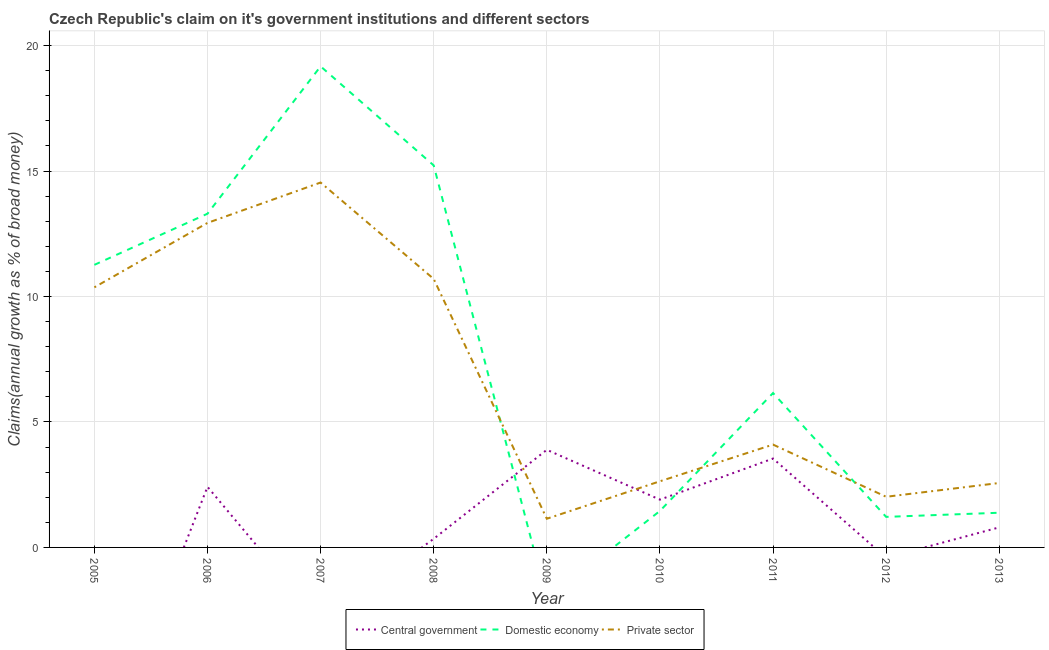How many different coloured lines are there?
Keep it short and to the point. 3. Does the line corresponding to percentage of claim on the domestic economy intersect with the line corresponding to percentage of claim on the private sector?
Your answer should be compact. Yes. Is the number of lines equal to the number of legend labels?
Your answer should be very brief. No. What is the percentage of claim on the private sector in 2007?
Your answer should be very brief. 14.54. Across all years, what is the maximum percentage of claim on the domestic economy?
Keep it short and to the point. 19.17. In which year was the percentage of claim on the domestic economy maximum?
Provide a succinct answer. 2007. What is the total percentage of claim on the domestic economy in the graph?
Offer a very short reply. 69.17. What is the difference between the percentage of claim on the domestic economy in 2007 and that in 2012?
Ensure brevity in your answer.  17.96. What is the difference between the percentage of claim on the domestic economy in 2010 and the percentage of claim on the central government in 2008?
Make the answer very short. 1.11. What is the average percentage of claim on the private sector per year?
Give a very brief answer. 6.78. In the year 2011, what is the difference between the percentage of claim on the private sector and percentage of claim on the domestic economy?
Ensure brevity in your answer.  -2.05. In how many years, is the percentage of claim on the central government greater than 1 %?
Make the answer very short. 4. What is the ratio of the percentage of claim on the private sector in 2008 to that in 2010?
Offer a very short reply. 4.06. Is the percentage of claim on the central government in 2009 less than that in 2011?
Your answer should be very brief. No. Is the difference between the percentage of claim on the domestic economy in 2010 and 2011 greater than the difference between the percentage of claim on the private sector in 2010 and 2011?
Offer a terse response. No. What is the difference between the highest and the second highest percentage of claim on the central government?
Your answer should be compact. 0.35. What is the difference between the highest and the lowest percentage of claim on the domestic economy?
Your response must be concise. 19.17. Is the sum of the percentage of claim on the domestic economy in 2008 and 2013 greater than the maximum percentage of claim on the private sector across all years?
Your response must be concise. Yes. Is the percentage of claim on the central government strictly greater than the percentage of claim on the domestic economy over the years?
Provide a succinct answer. No. How many lines are there?
Offer a very short reply. 3. How many years are there in the graph?
Your answer should be very brief. 9. What is the difference between two consecutive major ticks on the Y-axis?
Make the answer very short. 5. Does the graph contain any zero values?
Your answer should be very brief. Yes. How many legend labels are there?
Your response must be concise. 3. What is the title of the graph?
Your answer should be compact. Czech Republic's claim on it's government institutions and different sectors. Does "Infant(male)" appear as one of the legend labels in the graph?
Offer a very short reply. No. What is the label or title of the Y-axis?
Keep it short and to the point. Claims(annual growth as % of broad money). What is the Claims(annual growth as % of broad money) in Central government in 2005?
Your answer should be compact. 0. What is the Claims(annual growth as % of broad money) of Domestic economy in 2005?
Provide a short and direct response. 11.26. What is the Claims(annual growth as % of broad money) in Private sector in 2005?
Provide a succinct answer. 10.37. What is the Claims(annual growth as % of broad money) in Central government in 2006?
Your answer should be very brief. 2.42. What is the Claims(annual growth as % of broad money) in Domestic economy in 2006?
Keep it short and to the point. 13.3. What is the Claims(annual growth as % of broad money) in Private sector in 2006?
Offer a terse response. 12.93. What is the Claims(annual growth as % of broad money) of Central government in 2007?
Ensure brevity in your answer.  0. What is the Claims(annual growth as % of broad money) of Domestic economy in 2007?
Your answer should be very brief. 19.17. What is the Claims(annual growth as % of broad money) in Private sector in 2007?
Your answer should be very brief. 14.54. What is the Claims(annual growth as % of broad money) of Central government in 2008?
Give a very brief answer. 0.34. What is the Claims(annual growth as % of broad money) of Domestic economy in 2008?
Your response must be concise. 15.22. What is the Claims(annual growth as % of broad money) of Private sector in 2008?
Make the answer very short. 10.7. What is the Claims(annual growth as % of broad money) in Central government in 2009?
Make the answer very short. 3.89. What is the Claims(annual growth as % of broad money) of Domestic economy in 2009?
Your response must be concise. 0. What is the Claims(annual growth as % of broad money) of Private sector in 2009?
Your answer should be very brief. 1.14. What is the Claims(annual growth as % of broad money) of Central government in 2010?
Offer a terse response. 1.9. What is the Claims(annual growth as % of broad money) of Domestic economy in 2010?
Provide a succinct answer. 1.45. What is the Claims(annual growth as % of broad money) in Private sector in 2010?
Ensure brevity in your answer.  2.64. What is the Claims(annual growth as % of broad money) in Central government in 2011?
Give a very brief answer. 3.54. What is the Claims(annual growth as % of broad money) in Domestic economy in 2011?
Make the answer very short. 6.15. What is the Claims(annual growth as % of broad money) of Private sector in 2011?
Offer a very short reply. 4.1. What is the Claims(annual growth as % of broad money) of Domestic economy in 2012?
Your response must be concise. 1.22. What is the Claims(annual growth as % of broad money) in Private sector in 2012?
Give a very brief answer. 2.02. What is the Claims(annual growth as % of broad money) of Central government in 2013?
Your answer should be compact. 0.8. What is the Claims(annual growth as % of broad money) in Domestic economy in 2013?
Your answer should be very brief. 1.38. What is the Claims(annual growth as % of broad money) in Private sector in 2013?
Your answer should be compact. 2.57. Across all years, what is the maximum Claims(annual growth as % of broad money) of Central government?
Make the answer very short. 3.89. Across all years, what is the maximum Claims(annual growth as % of broad money) of Domestic economy?
Keep it short and to the point. 19.17. Across all years, what is the maximum Claims(annual growth as % of broad money) of Private sector?
Offer a very short reply. 14.54. Across all years, what is the minimum Claims(annual growth as % of broad money) in Central government?
Your answer should be compact. 0. Across all years, what is the minimum Claims(annual growth as % of broad money) in Private sector?
Keep it short and to the point. 1.14. What is the total Claims(annual growth as % of broad money) in Central government in the graph?
Keep it short and to the point. 12.9. What is the total Claims(annual growth as % of broad money) of Domestic economy in the graph?
Your answer should be very brief. 69.17. What is the total Claims(annual growth as % of broad money) in Private sector in the graph?
Keep it short and to the point. 61. What is the difference between the Claims(annual growth as % of broad money) of Domestic economy in 2005 and that in 2006?
Offer a terse response. -2.04. What is the difference between the Claims(annual growth as % of broad money) of Private sector in 2005 and that in 2006?
Provide a succinct answer. -2.57. What is the difference between the Claims(annual growth as % of broad money) of Domestic economy in 2005 and that in 2007?
Offer a terse response. -7.91. What is the difference between the Claims(annual growth as % of broad money) of Private sector in 2005 and that in 2007?
Make the answer very short. -4.18. What is the difference between the Claims(annual growth as % of broad money) in Domestic economy in 2005 and that in 2008?
Offer a terse response. -3.96. What is the difference between the Claims(annual growth as % of broad money) in Private sector in 2005 and that in 2008?
Ensure brevity in your answer.  -0.33. What is the difference between the Claims(annual growth as % of broad money) in Private sector in 2005 and that in 2009?
Make the answer very short. 9.22. What is the difference between the Claims(annual growth as % of broad money) of Domestic economy in 2005 and that in 2010?
Your answer should be very brief. 9.81. What is the difference between the Claims(annual growth as % of broad money) in Private sector in 2005 and that in 2010?
Your answer should be very brief. 7.73. What is the difference between the Claims(annual growth as % of broad money) of Domestic economy in 2005 and that in 2011?
Give a very brief answer. 5.11. What is the difference between the Claims(annual growth as % of broad money) of Private sector in 2005 and that in 2011?
Offer a terse response. 6.27. What is the difference between the Claims(annual growth as % of broad money) in Domestic economy in 2005 and that in 2012?
Your response must be concise. 10.04. What is the difference between the Claims(annual growth as % of broad money) of Private sector in 2005 and that in 2012?
Ensure brevity in your answer.  8.35. What is the difference between the Claims(annual growth as % of broad money) in Domestic economy in 2005 and that in 2013?
Your answer should be compact. 9.88. What is the difference between the Claims(annual growth as % of broad money) in Private sector in 2005 and that in 2013?
Your answer should be compact. 7.8. What is the difference between the Claims(annual growth as % of broad money) in Domestic economy in 2006 and that in 2007?
Ensure brevity in your answer.  -5.87. What is the difference between the Claims(annual growth as % of broad money) in Private sector in 2006 and that in 2007?
Keep it short and to the point. -1.61. What is the difference between the Claims(annual growth as % of broad money) of Central government in 2006 and that in 2008?
Provide a short and direct response. 2.07. What is the difference between the Claims(annual growth as % of broad money) of Domestic economy in 2006 and that in 2008?
Ensure brevity in your answer.  -1.93. What is the difference between the Claims(annual growth as % of broad money) in Private sector in 2006 and that in 2008?
Your response must be concise. 2.23. What is the difference between the Claims(annual growth as % of broad money) in Central government in 2006 and that in 2009?
Offer a very short reply. -1.48. What is the difference between the Claims(annual growth as % of broad money) in Private sector in 2006 and that in 2009?
Provide a short and direct response. 11.79. What is the difference between the Claims(annual growth as % of broad money) in Central government in 2006 and that in 2010?
Ensure brevity in your answer.  0.51. What is the difference between the Claims(annual growth as % of broad money) of Domestic economy in 2006 and that in 2010?
Your answer should be compact. 11.84. What is the difference between the Claims(annual growth as % of broad money) in Private sector in 2006 and that in 2010?
Ensure brevity in your answer.  10.3. What is the difference between the Claims(annual growth as % of broad money) in Central government in 2006 and that in 2011?
Make the answer very short. -1.13. What is the difference between the Claims(annual growth as % of broad money) in Domestic economy in 2006 and that in 2011?
Your response must be concise. 7.15. What is the difference between the Claims(annual growth as % of broad money) in Private sector in 2006 and that in 2011?
Ensure brevity in your answer.  8.83. What is the difference between the Claims(annual growth as % of broad money) of Domestic economy in 2006 and that in 2012?
Your answer should be very brief. 12.08. What is the difference between the Claims(annual growth as % of broad money) of Private sector in 2006 and that in 2012?
Your answer should be compact. 10.91. What is the difference between the Claims(annual growth as % of broad money) in Central government in 2006 and that in 2013?
Offer a very short reply. 1.62. What is the difference between the Claims(annual growth as % of broad money) in Domestic economy in 2006 and that in 2013?
Your answer should be compact. 11.92. What is the difference between the Claims(annual growth as % of broad money) in Private sector in 2006 and that in 2013?
Make the answer very short. 10.36. What is the difference between the Claims(annual growth as % of broad money) of Domestic economy in 2007 and that in 2008?
Provide a short and direct response. 3.95. What is the difference between the Claims(annual growth as % of broad money) of Private sector in 2007 and that in 2008?
Your answer should be compact. 3.84. What is the difference between the Claims(annual growth as % of broad money) in Private sector in 2007 and that in 2009?
Give a very brief answer. 13.4. What is the difference between the Claims(annual growth as % of broad money) in Domestic economy in 2007 and that in 2010?
Make the answer very short. 17.72. What is the difference between the Claims(annual growth as % of broad money) in Private sector in 2007 and that in 2010?
Provide a short and direct response. 11.91. What is the difference between the Claims(annual growth as % of broad money) of Domestic economy in 2007 and that in 2011?
Offer a very short reply. 13.02. What is the difference between the Claims(annual growth as % of broad money) in Private sector in 2007 and that in 2011?
Provide a short and direct response. 10.44. What is the difference between the Claims(annual growth as % of broad money) in Domestic economy in 2007 and that in 2012?
Your answer should be very brief. 17.96. What is the difference between the Claims(annual growth as % of broad money) of Private sector in 2007 and that in 2012?
Your response must be concise. 12.52. What is the difference between the Claims(annual growth as % of broad money) in Domestic economy in 2007 and that in 2013?
Your answer should be compact. 17.79. What is the difference between the Claims(annual growth as % of broad money) of Private sector in 2007 and that in 2013?
Ensure brevity in your answer.  11.97. What is the difference between the Claims(annual growth as % of broad money) in Central government in 2008 and that in 2009?
Keep it short and to the point. -3.55. What is the difference between the Claims(annual growth as % of broad money) of Private sector in 2008 and that in 2009?
Give a very brief answer. 9.56. What is the difference between the Claims(annual growth as % of broad money) of Central government in 2008 and that in 2010?
Offer a terse response. -1.56. What is the difference between the Claims(annual growth as % of broad money) in Domestic economy in 2008 and that in 2010?
Make the answer very short. 13.77. What is the difference between the Claims(annual growth as % of broad money) in Private sector in 2008 and that in 2010?
Offer a very short reply. 8.06. What is the difference between the Claims(annual growth as % of broad money) of Central government in 2008 and that in 2011?
Make the answer very short. -3.2. What is the difference between the Claims(annual growth as % of broad money) of Domestic economy in 2008 and that in 2011?
Make the answer very short. 9.07. What is the difference between the Claims(annual growth as % of broad money) of Private sector in 2008 and that in 2011?
Provide a short and direct response. 6.6. What is the difference between the Claims(annual growth as % of broad money) in Domestic economy in 2008 and that in 2012?
Give a very brief answer. 14.01. What is the difference between the Claims(annual growth as % of broad money) in Private sector in 2008 and that in 2012?
Provide a short and direct response. 8.68. What is the difference between the Claims(annual growth as % of broad money) in Central government in 2008 and that in 2013?
Your answer should be very brief. -0.46. What is the difference between the Claims(annual growth as % of broad money) of Domestic economy in 2008 and that in 2013?
Offer a very short reply. 13.84. What is the difference between the Claims(annual growth as % of broad money) in Private sector in 2008 and that in 2013?
Keep it short and to the point. 8.13. What is the difference between the Claims(annual growth as % of broad money) in Central government in 2009 and that in 2010?
Make the answer very short. 1.99. What is the difference between the Claims(annual growth as % of broad money) in Private sector in 2009 and that in 2010?
Provide a succinct answer. -1.49. What is the difference between the Claims(annual growth as % of broad money) of Central government in 2009 and that in 2011?
Ensure brevity in your answer.  0.35. What is the difference between the Claims(annual growth as % of broad money) of Private sector in 2009 and that in 2011?
Your response must be concise. -2.95. What is the difference between the Claims(annual growth as % of broad money) in Private sector in 2009 and that in 2012?
Offer a very short reply. -0.88. What is the difference between the Claims(annual growth as % of broad money) of Central government in 2009 and that in 2013?
Provide a succinct answer. 3.09. What is the difference between the Claims(annual growth as % of broad money) of Private sector in 2009 and that in 2013?
Your answer should be compact. -1.42. What is the difference between the Claims(annual growth as % of broad money) of Central government in 2010 and that in 2011?
Give a very brief answer. -1.64. What is the difference between the Claims(annual growth as % of broad money) of Domestic economy in 2010 and that in 2011?
Offer a terse response. -4.7. What is the difference between the Claims(annual growth as % of broad money) in Private sector in 2010 and that in 2011?
Your answer should be compact. -1.46. What is the difference between the Claims(annual growth as % of broad money) in Domestic economy in 2010 and that in 2012?
Keep it short and to the point. 0.24. What is the difference between the Claims(annual growth as % of broad money) of Private sector in 2010 and that in 2012?
Provide a succinct answer. 0.62. What is the difference between the Claims(annual growth as % of broad money) of Central government in 2010 and that in 2013?
Ensure brevity in your answer.  1.1. What is the difference between the Claims(annual growth as % of broad money) of Domestic economy in 2010 and that in 2013?
Make the answer very short. 0.07. What is the difference between the Claims(annual growth as % of broad money) of Private sector in 2010 and that in 2013?
Your answer should be very brief. 0.07. What is the difference between the Claims(annual growth as % of broad money) in Domestic economy in 2011 and that in 2012?
Offer a terse response. 4.94. What is the difference between the Claims(annual growth as % of broad money) of Private sector in 2011 and that in 2012?
Your response must be concise. 2.08. What is the difference between the Claims(annual growth as % of broad money) in Central government in 2011 and that in 2013?
Provide a succinct answer. 2.74. What is the difference between the Claims(annual growth as % of broad money) in Domestic economy in 2011 and that in 2013?
Give a very brief answer. 4.77. What is the difference between the Claims(annual growth as % of broad money) of Private sector in 2011 and that in 2013?
Your response must be concise. 1.53. What is the difference between the Claims(annual growth as % of broad money) in Domestic economy in 2012 and that in 2013?
Give a very brief answer. -0.17. What is the difference between the Claims(annual growth as % of broad money) in Private sector in 2012 and that in 2013?
Make the answer very short. -0.55. What is the difference between the Claims(annual growth as % of broad money) in Domestic economy in 2005 and the Claims(annual growth as % of broad money) in Private sector in 2006?
Provide a short and direct response. -1.67. What is the difference between the Claims(annual growth as % of broad money) of Domestic economy in 2005 and the Claims(annual growth as % of broad money) of Private sector in 2007?
Make the answer very short. -3.28. What is the difference between the Claims(annual growth as % of broad money) of Domestic economy in 2005 and the Claims(annual growth as % of broad money) of Private sector in 2008?
Offer a very short reply. 0.56. What is the difference between the Claims(annual growth as % of broad money) in Domestic economy in 2005 and the Claims(annual growth as % of broad money) in Private sector in 2009?
Your answer should be compact. 10.12. What is the difference between the Claims(annual growth as % of broad money) of Domestic economy in 2005 and the Claims(annual growth as % of broad money) of Private sector in 2010?
Your answer should be compact. 8.63. What is the difference between the Claims(annual growth as % of broad money) of Domestic economy in 2005 and the Claims(annual growth as % of broad money) of Private sector in 2011?
Your response must be concise. 7.16. What is the difference between the Claims(annual growth as % of broad money) of Domestic economy in 2005 and the Claims(annual growth as % of broad money) of Private sector in 2012?
Your answer should be very brief. 9.24. What is the difference between the Claims(annual growth as % of broad money) in Domestic economy in 2005 and the Claims(annual growth as % of broad money) in Private sector in 2013?
Provide a succinct answer. 8.69. What is the difference between the Claims(annual growth as % of broad money) in Central government in 2006 and the Claims(annual growth as % of broad money) in Domestic economy in 2007?
Your answer should be very brief. -16.76. What is the difference between the Claims(annual growth as % of broad money) in Central government in 2006 and the Claims(annual growth as % of broad money) in Private sector in 2007?
Keep it short and to the point. -12.13. What is the difference between the Claims(annual growth as % of broad money) in Domestic economy in 2006 and the Claims(annual growth as % of broad money) in Private sector in 2007?
Offer a terse response. -1.24. What is the difference between the Claims(annual growth as % of broad money) of Central government in 2006 and the Claims(annual growth as % of broad money) of Domestic economy in 2008?
Your response must be concise. -12.81. What is the difference between the Claims(annual growth as % of broad money) in Central government in 2006 and the Claims(annual growth as % of broad money) in Private sector in 2008?
Ensure brevity in your answer.  -8.28. What is the difference between the Claims(annual growth as % of broad money) in Domestic economy in 2006 and the Claims(annual growth as % of broad money) in Private sector in 2008?
Offer a terse response. 2.6. What is the difference between the Claims(annual growth as % of broad money) of Central government in 2006 and the Claims(annual growth as % of broad money) of Private sector in 2009?
Offer a terse response. 1.27. What is the difference between the Claims(annual growth as % of broad money) of Domestic economy in 2006 and the Claims(annual growth as % of broad money) of Private sector in 2009?
Provide a succinct answer. 12.16. What is the difference between the Claims(annual growth as % of broad money) in Central government in 2006 and the Claims(annual growth as % of broad money) in Domestic economy in 2010?
Give a very brief answer. 0.96. What is the difference between the Claims(annual growth as % of broad money) of Central government in 2006 and the Claims(annual growth as % of broad money) of Private sector in 2010?
Keep it short and to the point. -0.22. What is the difference between the Claims(annual growth as % of broad money) in Domestic economy in 2006 and the Claims(annual growth as % of broad money) in Private sector in 2010?
Your response must be concise. 10.66. What is the difference between the Claims(annual growth as % of broad money) in Central government in 2006 and the Claims(annual growth as % of broad money) in Domestic economy in 2011?
Your answer should be compact. -3.74. What is the difference between the Claims(annual growth as % of broad money) in Central government in 2006 and the Claims(annual growth as % of broad money) in Private sector in 2011?
Offer a very short reply. -1.68. What is the difference between the Claims(annual growth as % of broad money) of Domestic economy in 2006 and the Claims(annual growth as % of broad money) of Private sector in 2011?
Make the answer very short. 9.2. What is the difference between the Claims(annual growth as % of broad money) of Central government in 2006 and the Claims(annual growth as % of broad money) of Domestic economy in 2012?
Ensure brevity in your answer.  1.2. What is the difference between the Claims(annual growth as % of broad money) of Central government in 2006 and the Claims(annual growth as % of broad money) of Private sector in 2012?
Offer a terse response. 0.4. What is the difference between the Claims(annual growth as % of broad money) in Domestic economy in 2006 and the Claims(annual growth as % of broad money) in Private sector in 2012?
Your answer should be compact. 11.28. What is the difference between the Claims(annual growth as % of broad money) in Central government in 2006 and the Claims(annual growth as % of broad money) in Domestic economy in 2013?
Give a very brief answer. 1.03. What is the difference between the Claims(annual growth as % of broad money) of Central government in 2006 and the Claims(annual growth as % of broad money) of Private sector in 2013?
Ensure brevity in your answer.  -0.15. What is the difference between the Claims(annual growth as % of broad money) of Domestic economy in 2006 and the Claims(annual growth as % of broad money) of Private sector in 2013?
Provide a short and direct response. 10.73. What is the difference between the Claims(annual growth as % of broad money) of Domestic economy in 2007 and the Claims(annual growth as % of broad money) of Private sector in 2008?
Ensure brevity in your answer.  8.47. What is the difference between the Claims(annual growth as % of broad money) of Domestic economy in 2007 and the Claims(annual growth as % of broad money) of Private sector in 2009?
Your answer should be very brief. 18.03. What is the difference between the Claims(annual growth as % of broad money) of Domestic economy in 2007 and the Claims(annual growth as % of broad money) of Private sector in 2010?
Keep it short and to the point. 16.54. What is the difference between the Claims(annual growth as % of broad money) of Domestic economy in 2007 and the Claims(annual growth as % of broad money) of Private sector in 2011?
Keep it short and to the point. 15.07. What is the difference between the Claims(annual growth as % of broad money) in Domestic economy in 2007 and the Claims(annual growth as % of broad money) in Private sector in 2012?
Make the answer very short. 17.15. What is the difference between the Claims(annual growth as % of broad money) in Domestic economy in 2007 and the Claims(annual growth as % of broad money) in Private sector in 2013?
Offer a terse response. 16.6. What is the difference between the Claims(annual growth as % of broad money) of Central government in 2008 and the Claims(annual growth as % of broad money) of Private sector in 2009?
Your response must be concise. -0.8. What is the difference between the Claims(annual growth as % of broad money) in Domestic economy in 2008 and the Claims(annual growth as % of broad money) in Private sector in 2009?
Your response must be concise. 14.08. What is the difference between the Claims(annual growth as % of broad money) of Central government in 2008 and the Claims(annual growth as % of broad money) of Domestic economy in 2010?
Offer a very short reply. -1.11. What is the difference between the Claims(annual growth as % of broad money) of Central government in 2008 and the Claims(annual growth as % of broad money) of Private sector in 2010?
Your response must be concise. -2.29. What is the difference between the Claims(annual growth as % of broad money) in Domestic economy in 2008 and the Claims(annual growth as % of broad money) in Private sector in 2010?
Ensure brevity in your answer.  12.59. What is the difference between the Claims(annual growth as % of broad money) in Central government in 2008 and the Claims(annual growth as % of broad money) in Domestic economy in 2011?
Offer a terse response. -5.81. What is the difference between the Claims(annual growth as % of broad money) in Central government in 2008 and the Claims(annual growth as % of broad money) in Private sector in 2011?
Keep it short and to the point. -3.75. What is the difference between the Claims(annual growth as % of broad money) of Domestic economy in 2008 and the Claims(annual growth as % of broad money) of Private sector in 2011?
Give a very brief answer. 11.13. What is the difference between the Claims(annual growth as % of broad money) of Central government in 2008 and the Claims(annual growth as % of broad money) of Domestic economy in 2012?
Keep it short and to the point. -0.87. What is the difference between the Claims(annual growth as % of broad money) of Central government in 2008 and the Claims(annual growth as % of broad money) of Private sector in 2012?
Your answer should be compact. -1.67. What is the difference between the Claims(annual growth as % of broad money) in Domestic economy in 2008 and the Claims(annual growth as % of broad money) in Private sector in 2012?
Offer a very short reply. 13.21. What is the difference between the Claims(annual growth as % of broad money) in Central government in 2008 and the Claims(annual growth as % of broad money) in Domestic economy in 2013?
Your answer should be very brief. -1.04. What is the difference between the Claims(annual growth as % of broad money) of Central government in 2008 and the Claims(annual growth as % of broad money) of Private sector in 2013?
Give a very brief answer. -2.22. What is the difference between the Claims(annual growth as % of broad money) of Domestic economy in 2008 and the Claims(annual growth as % of broad money) of Private sector in 2013?
Ensure brevity in your answer.  12.66. What is the difference between the Claims(annual growth as % of broad money) of Central government in 2009 and the Claims(annual growth as % of broad money) of Domestic economy in 2010?
Make the answer very short. 2.44. What is the difference between the Claims(annual growth as % of broad money) of Central government in 2009 and the Claims(annual growth as % of broad money) of Private sector in 2010?
Make the answer very short. 1.25. What is the difference between the Claims(annual growth as % of broad money) of Central government in 2009 and the Claims(annual growth as % of broad money) of Domestic economy in 2011?
Your answer should be very brief. -2.26. What is the difference between the Claims(annual growth as % of broad money) of Central government in 2009 and the Claims(annual growth as % of broad money) of Private sector in 2011?
Provide a succinct answer. -0.21. What is the difference between the Claims(annual growth as % of broad money) of Central government in 2009 and the Claims(annual growth as % of broad money) of Domestic economy in 2012?
Ensure brevity in your answer.  2.67. What is the difference between the Claims(annual growth as % of broad money) in Central government in 2009 and the Claims(annual growth as % of broad money) in Private sector in 2012?
Give a very brief answer. 1.87. What is the difference between the Claims(annual growth as % of broad money) of Central government in 2009 and the Claims(annual growth as % of broad money) of Domestic economy in 2013?
Offer a terse response. 2.51. What is the difference between the Claims(annual growth as % of broad money) in Central government in 2009 and the Claims(annual growth as % of broad money) in Private sector in 2013?
Provide a short and direct response. 1.32. What is the difference between the Claims(annual growth as % of broad money) of Central government in 2010 and the Claims(annual growth as % of broad money) of Domestic economy in 2011?
Make the answer very short. -4.25. What is the difference between the Claims(annual growth as % of broad money) in Central government in 2010 and the Claims(annual growth as % of broad money) in Private sector in 2011?
Offer a very short reply. -2.19. What is the difference between the Claims(annual growth as % of broad money) in Domestic economy in 2010 and the Claims(annual growth as % of broad money) in Private sector in 2011?
Offer a terse response. -2.64. What is the difference between the Claims(annual growth as % of broad money) in Central government in 2010 and the Claims(annual growth as % of broad money) in Domestic economy in 2012?
Your response must be concise. 0.69. What is the difference between the Claims(annual growth as % of broad money) of Central government in 2010 and the Claims(annual growth as % of broad money) of Private sector in 2012?
Offer a terse response. -0.11. What is the difference between the Claims(annual growth as % of broad money) of Domestic economy in 2010 and the Claims(annual growth as % of broad money) of Private sector in 2012?
Give a very brief answer. -0.56. What is the difference between the Claims(annual growth as % of broad money) in Central government in 2010 and the Claims(annual growth as % of broad money) in Domestic economy in 2013?
Your answer should be very brief. 0.52. What is the difference between the Claims(annual growth as % of broad money) of Central government in 2010 and the Claims(annual growth as % of broad money) of Private sector in 2013?
Ensure brevity in your answer.  -0.66. What is the difference between the Claims(annual growth as % of broad money) of Domestic economy in 2010 and the Claims(annual growth as % of broad money) of Private sector in 2013?
Your answer should be compact. -1.11. What is the difference between the Claims(annual growth as % of broad money) of Central government in 2011 and the Claims(annual growth as % of broad money) of Domestic economy in 2012?
Keep it short and to the point. 2.33. What is the difference between the Claims(annual growth as % of broad money) of Central government in 2011 and the Claims(annual growth as % of broad money) of Private sector in 2012?
Your response must be concise. 1.52. What is the difference between the Claims(annual growth as % of broad money) in Domestic economy in 2011 and the Claims(annual growth as % of broad money) in Private sector in 2012?
Ensure brevity in your answer.  4.13. What is the difference between the Claims(annual growth as % of broad money) of Central government in 2011 and the Claims(annual growth as % of broad money) of Domestic economy in 2013?
Provide a succinct answer. 2.16. What is the difference between the Claims(annual growth as % of broad money) in Central government in 2011 and the Claims(annual growth as % of broad money) in Private sector in 2013?
Your answer should be very brief. 0.97. What is the difference between the Claims(annual growth as % of broad money) in Domestic economy in 2011 and the Claims(annual growth as % of broad money) in Private sector in 2013?
Provide a succinct answer. 3.58. What is the difference between the Claims(annual growth as % of broad money) of Domestic economy in 2012 and the Claims(annual growth as % of broad money) of Private sector in 2013?
Your response must be concise. -1.35. What is the average Claims(annual growth as % of broad money) of Central government per year?
Keep it short and to the point. 1.43. What is the average Claims(annual growth as % of broad money) of Domestic economy per year?
Offer a terse response. 7.68. What is the average Claims(annual growth as % of broad money) of Private sector per year?
Your answer should be compact. 6.78. In the year 2005, what is the difference between the Claims(annual growth as % of broad money) in Domestic economy and Claims(annual growth as % of broad money) in Private sector?
Offer a terse response. 0.9. In the year 2006, what is the difference between the Claims(annual growth as % of broad money) in Central government and Claims(annual growth as % of broad money) in Domestic economy?
Offer a terse response. -10.88. In the year 2006, what is the difference between the Claims(annual growth as % of broad money) in Central government and Claims(annual growth as % of broad money) in Private sector?
Make the answer very short. -10.52. In the year 2006, what is the difference between the Claims(annual growth as % of broad money) of Domestic economy and Claims(annual growth as % of broad money) of Private sector?
Give a very brief answer. 0.37. In the year 2007, what is the difference between the Claims(annual growth as % of broad money) in Domestic economy and Claims(annual growth as % of broad money) in Private sector?
Make the answer very short. 4.63. In the year 2008, what is the difference between the Claims(annual growth as % of broad money) in Central government and Claims(annual growth as % of broad money) in Domestic economy?
Provide a succinct answer. -14.88. In the year 2008, what is the difference between the Claims(annual growth as % of broad money) of Central government and Claims(annual growth as % of broad money) of Private sector?
Give a very brief answer. -10.36. In the year 2008, what is the difference between the Claims(annual growth as % of broad money) in Domestic economy and Claims(annual growth as % of broad money) in Private sector?
Provide a short and direct response. 4.52. In the year 2009, what is the difference between the Claims(annual growth as % of broad money) of Central government and Claims(annual growth as % of broad money) of Private sector?
Offer a terse response. 2.75. In the year 2010, what is the difference between the Claims(annual growth as % of broad money) in Central government and Claims(annual growth as % of broad money) in Domestic economy?
Offer a very short reply. 0.45. In the year 2010, what is the difference between the Claims(annual growth as % of broad money) in Central government and Claims(annual growth as % of broad money) in Private sector?
Your answer should be very brief. -0.73. In the year 2010, what is the difference between the Claims(annual growth as % of broad money) in Domestic economy and Claims(annual growth as % of broad money) in Private sector?
Ensure brevity in your answer.  -1.18. In the year 2011, what is the difference between the Claims(annual growth as % of broad money) in Central government and Claims(annual growth as % of broad money) in Domestic economy?
Give a very brief answer. -2.61. In the year 2011, what is the difference between the Claims(annual growth as % of broad money) of Central government and Claims(annual growth as % of broad money) of Private sector?
Keep it short and to the point. -0.56. In the year 2011, what is the difference between the Claims(annual growth as % of broad money) of Domestic economy and Claims(annual growth as % of broad money) of Private sector?
Provide a succinct answer. 2.05. In the year 2012, what is the difference between the Claims(annual growth as % of broad money) of Domestic economy and Claims(annual growth as % of broad money) of Private sector?
Provide a short and direct response. -0.8. In the year 2013, what is the difference between the Claims(annual growth as % of broad money) of Central government and Claims(annual growth as % of broad money) of Domestic economy?
Provide a short and direct response. -0.58. In the year 2013, what is the difference between the Claims(annual growth as % of broad money) of Central government and Claims(annual growth as % of broad money) of Private sector?
Your response must be concise. -1.77. In the year 2013, what is the difference between the Claims(annual growth as % of broad money) in Domestic economy and Claims(annual growth as % of broad money) in Private sector?
Make the answer very short. -1.19. What is the ratio of the Claims(annual growth as % of broad money) of Domestic economy in 2005 to that in 2006?
Give a very brief answer. 0.85. What is the ratio of the Claims(annual growth as % of broad money) of Private sector in 2005 to that in 2006?
Keep it short and to the point. 0.8. What is the ratio of the Claims(annual growth as % of broad money) of Domestic economy in 2005 to that in 2007?
Provide a succinct answer. 0.59. What is the ratio of the Claims(annual growth as % of broad money) of Private sector in 2005 to that in 2007?
Offer a terse response. 0.71. What is the ratio of the Claims(annual growth as % of broad money) in Domestic economy in 2005 to that in 2008?
Make the answer very short. 0.74. What is the ratio of the Claims(annual growth as % of broad money) of Private sector in 2005 to that in 2008?
Ensure brevity in your answer.  0.97. What is the ratio of the Claims(annual growth as % of broad money) of Private sector in 2005 to that in 2009?
Provide a short and direct response. 9.07. What is the ratio of the Claims(annual growth as % of broad money) in Domestic economy in 2005 to that in 2010?
Your answer should be compact. 7.74. What is the ratio of the Claims(annual growth as % of broad money) in Private sector in 2005 to that in 2010?
Give a very brief answer. 3.93. What is the ratio of the Claims(annual growth as % of broad money) in Domestic economy in 2005 to that in 2011?
Provide a succinct answer. 1.83. What is the ratio of the Claims(annual growth as % of broad money) of Private sector in 2005 to that in 2011?
Give a very brief answer. 2.53. What is the ratio of the Claims(annual growth as % of broad money) in Domestic economy in 2005 to that in 2012?
Offer a very short reply. 9.25. What is the ratio of the Claims(annual growth as % of broad money) in Private sector in 2005 to that in 2012?
Provide a succinct answer. 5.14. What is the ratio of the Claims(annual growth as % of broad money) in Domestic economy in 2005 to that in 2013?
Offer a terse response. 8.15. What is the ratio of the Claims(annual growth as % of broad money) in Private sector in 2005 to that in 2013?
Provide a short and direct response. 4.04. What is the ratio of the Claims(annual growth as % of broad money) in Domestic economy in 2006 to that in 2007?
Ensure brevity in your answer.  0.69. What is the ratio of the Claims(annual growth as % of broad money) of Private sector in 2006 to that in 2007?
Offer a terse response. 0.89. What is the ratio of the Claims(annual growth as % of broad money) in Central government in 2006 to that in 2008?
Offer a very short reply. 7.02. What is the ratio of the Claims(annual growth as % of broad money) of Domestic economy in 2006 to that in 2008?
Provide a succinct answer. 0.87. What is the ratio of the Claims(annual growth as % of broad money) of Private sector in 2006 to that in 2008?
Provide a succinct answer. 1.21. What is the ratio of the Claims(annual growth as % of broad money) in Central government in 2006 to that in 2009?
Your answer should be compact. 0.62. What is the ratio of the Claims(annual growth as % of broad money) of Private sector in 2006 to that in 2009?
Provide a short and direct response. 11.31. What is the ratio of the Claims(annual growth as % of broad money) in Central government in 2006 to that in 2010?
Your answer should be very brief. 1.27. What is the ratio of the Claims(annual growth as % of broad money) of Domestic economy in 2006 to that in 2010?
Keep it short and to the point. 9.15. What is the ratio of the Claims(annual growth as % of broad money) of Private sector in 2006 to that in 2010?
Your answer should be very brief. 4.91. What is the ratio of the Claims(annual growth as % of broad money) in Central government in 2006 to that in 2011?
Make the answer very short. 0.68. What is the ratio of the Claims(annual growth as % of broad money) in Domestic economy in 2006 to that in 2011?
Keep it short and to the point. 2.16. What is the ratio of the Claims(annual growth as % of broad money) of Private sector in 2006 to that in 2011?
Ensure brevity in your answer.  3.16. What is the ratio of the Claims(annual growth as % of broad money) in Domestic economy in 2006 to that in 2012?
Ensure brevity in your answer.  10.93. What is the ratio of the Claims(annual growth as % of broad money) in Private sector in 2006 to that in 2012?
Your answer should be very brief. 6.41. What is the ratio of the Claims(annual growth as % of broad money) in Central government in 2006 to that in 2013?
Keep it short and to the point. 3.02. What is the ratio of the Claims(annual growth as % of broad money) in Domestic economy in 2006 to that in 2013?
Provide a short and direct response. 9.62. What is the ratio of the Claims(annual growth as % of broad money) in Private sector in 2006 to that in 2013?
Provide a short and direct response. 5.04. What is the ratio of the Claims(annual growth as % of broad money) of Domestic economy in 2007 to that in 2008?
Offer a terse response. 1.26. What is the ratio of the Claims(annual growth as % of broad money) in Private sector in 2007 to that in 2008?
Your answer should be very brief. 1.36. What is the ratio of the Claims(annual growth as % of broad money) in Private sector in 2007 to that in 2009?
Make the answer very short. 12.72. What is the ratio of the Claims(annual growth as % of broad money) in Domestic economy in 2007 to that in 2010?
Keep it short and to the point. 13.18. What is the ratio of the Claims(annual growth as % of broad money) in Private sector in 2007 to that in 2010?
Offer a terse response. 5.52. What is the ratio of the Claims(annual growth as % of broad money) of Domestic economy in 2007 to that in 2011?
Your answer should be compact. 3.12. What is the ratio of the Claims(annual growth as % of broad money) in Private sector in 2007 to that in 2011?
Offer a terse response. 3.55. What is the ratio of the Claims(annual growth as % of broad money) of Domestic economy in 2007 to that in 2012?
Ensure brevity in your answer.  15.75. What is the ratio of the Claims(annual growth as % of broad money) of Private sector in 2007 to that in 2012?
Ensure brevity in your answer.  7.21. What is the ratio of the Claims(annual growth as % of broad money) in Domestic economy in 2007 to that in 2013?
Keep it short and to the point. 13.87. What is the ratio of the Claims(annual growth as % of broad money) in Private sector in 2007 to that in 2013?
Your answer should be very brief. 5.66. What is the ratio of the Claims(annual growth as % of broad money) in Central government in 2008 to that in 2009?
Give a very brief answer. 0.09. What is the ratio of the Claims(annual growth as % of broad money) of Private sector in 2008 to that in 2009?
Your answer should be very brief. 9.36. What is the ratio of the Claims(annual growth as % of broad money) of Central government in 2008 to that in 2010?
Your answer should be compact. 0.18. What is the ratio of the Claims(annual growth as % of broad money) in Domestic economy in 2008 to that in 2010?
Ensure brevity in your answer.  10.47. What is the ratio of the Claims(annual growth as % of broad money) of Private sector in 2008 to that in 2010?
Keep it short and to the point. 4.06. What is the ratio of the Claims(annual growth as % of broad money) of Central government in 2008 to that in 2011?
Offer a very short reply. 0.1. What is the ratio of the Claims(annual growth as % of broad money) of Domestic economy in 2008 to that in 2011?
Provide a succinct answer. 2.47. What is the ratio of the Claims(annual growth as % of broad money) of Private sector in 2008 to that in 2011?
Offer a terse response. 2.61. What is the ratio of the Claims(annual growth as % of broad money) of Domestic economy in 2008 to that in 2012?
Your answer should be compact. 12.51. What is the ratio of the Claims(annual growth as % of broad money) of Private sector in 2008 to that in 2012?
Your answer should be compact. 5.3. What is the ratio of the Claims(annual growth as % of broad money) in Central government in 2008 to that in 2013?
Offer a terse response. 0.43. What is the ratio of the Claims(annual growth as % of broad money) of Domestic economy in 2008 to that in 2013?
Your answer should be very brief. 11.01. What is the ratio of the Claims(annual growth as % of broad money) of Private sector in 2008 to that in 2013?
Keep it short and to the point. 4.17. What is the ratio of the Claims(annual growth as % of broad money) in Central government in 2009 to that in 2010?
Your response must be concise. 2.04. What is the ratio of the Claims(annual growth as % of broad money) in Private sector in 2009 to that in 2010?
Make the answer very short. 0.43. What is the ratio of the Claims(annual growth as % of broad money) of Central government in 2009 to that in 2011?
Offer a terse response. 1.1. What is the ratio of the Claims(annual growth as % of broad money) in Private sector in 2009 to that in 2011?
Offer a very short reply. 0.28. What is the ratio of the Claims(annual growth as % of broad money) in Private sector in 2009 to that in 2012?
Offer a very short reply. 0.57. What is the ratio of the Claims(annual growth as % of broad money) of Central government in 2009 to that in 2013?
Keep it short and to the point. 4.87. What is the ratio of the Claims(annual growth as % of broad money) in Private sector in 2009 to that in 2013?
Provide a short and direct response. 0.45. What is the ratio of the Claims(annual growth as % of broad money) in Central government in 2010 to that in 2011?
Give a very brief answer. 0.54. What is the ratio of the Claims(annual growth as % of broad money) in Domestic economy in 2010 to that in 2011?
Give a very brief answer. 0.24. What is the ratio of the Claims(annual growth as % of broad money) in Private sector in 2010 to that in 2011?
Provide a succinct answer. 0.64. What is the ratio of the Claims(annual growth as % of broad money) of Domestic economy in 2010 to that in 2012?
Keep it short and to the point. 1.19. What is the ratio of the Claims(annual growth as % of broad money) in Private sector in 2010 to that in 2012?
Provide a short and direct response. 1.31. What is the ratio of the Claims(annual growth as % of broad money) of Central government in 2010 to that in 2013?
Ensure brevity in your answer.  2.38. What is the ratio of the Claims(annual growth as % of broad money) in Domestic economy in 2010 to that in 2013?
Give a very brief answer. 1.05. What is the ratio of the Claims(annual growth as % of broad money) of Private sector in 2010 to that in 2013?
Provide a short and direct response. 1.03. What is the ratio of the Claims(annual growth as % of broad money) of Domestic economy in 2011 to that in 2012?
Keep it short and to the point. 5.05. What is the ratio of the Claims(annual growth as % of broad money) of Private sector in 2011 to that in 2012?
Your response must be concise. 2.03. What is the ratio of the Claims(annual growth as % of broad money) of Central government in 2011 to that in 2013?
Your response must be concise. 4.43. What is the ratio of the Claims(annual growth as % of broad money) in Domestic economy in 2011 to that in 2013?
Your answer should be very brief. 4.45. What is the ratio of the Claims(annual growth as % of broad money) of Private sector in 2011 to that in 2013?
Your answer should be compact. 1.6. What is the ratio of the Claims(annual growth as % of broad money) of Domestic economy in 2012 to that in 2013?
Keep it short and to the point. 0.88. What is the ratio of the Claims(annual growth as % of broad money) in Private sector in 2012 to that in 2013?
Offer a very short reply. 0.79. What is the difference between the highest and the second highest Claims(annual growth as % of broad money) in Central government?
Provide a short and direct response. 0.35. What is the difference between the highest and the second highest Claims(annual growth as % of broad money) in Domestic economy?
Provide a short and direct response. 3.95. What is the difference between the highest and the second highest Claims(annual growth as % of broad money) of Private sector?
Offer a very short reply. 1.61. What is the difference between the highest and the lowest Claims(annual growth as % of broad money) in Central government?
Your answer should be compact. 3.89. What is the difference between the highest and the lowest Claims(annual growth as % of broad money) of Domestic economy?
Give a very brief answer. 19.17. What is the difference between the highest and the lowest Claims(annual growth as % of broad money) in Private sector?
Ensure brevity in your answer.  13.4. 